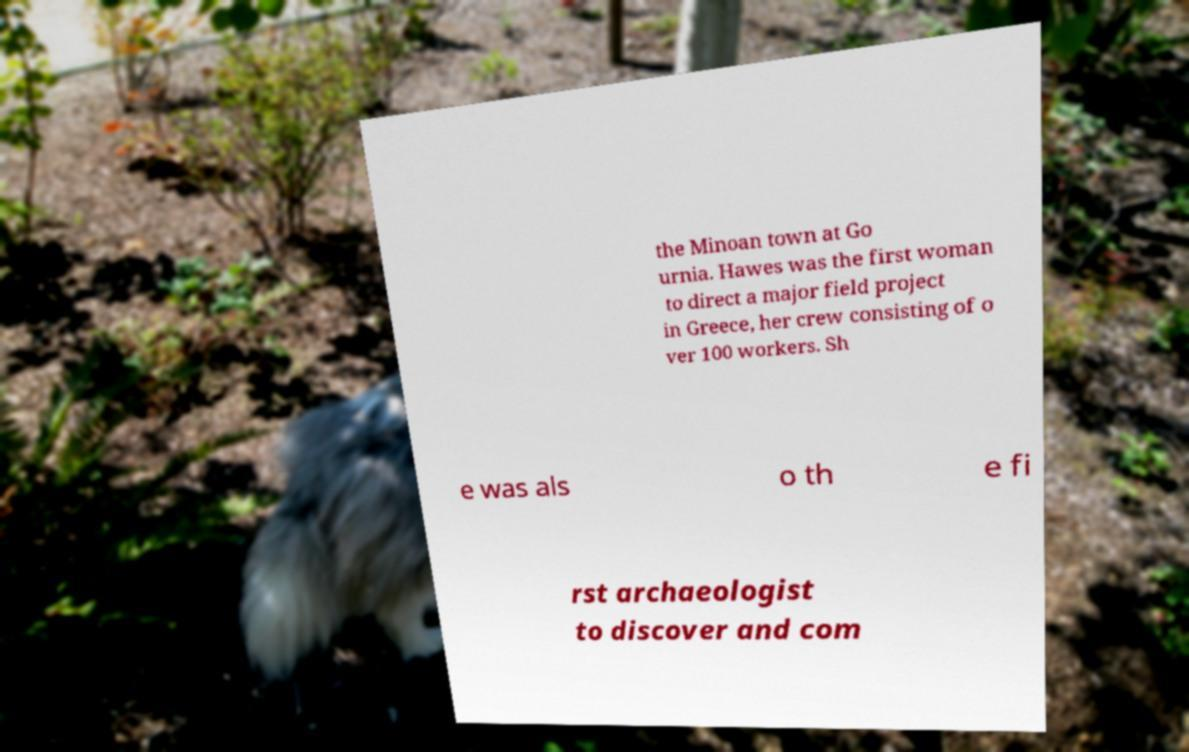Please identify and transcribe the text found in this image. the Minoan town at Go urnia. Hawes was the first woman to direct a major field project in Greece, her crew consisting of o ver 100 workers. Sh e was als o th e fi rst archaeologist to discover and com 